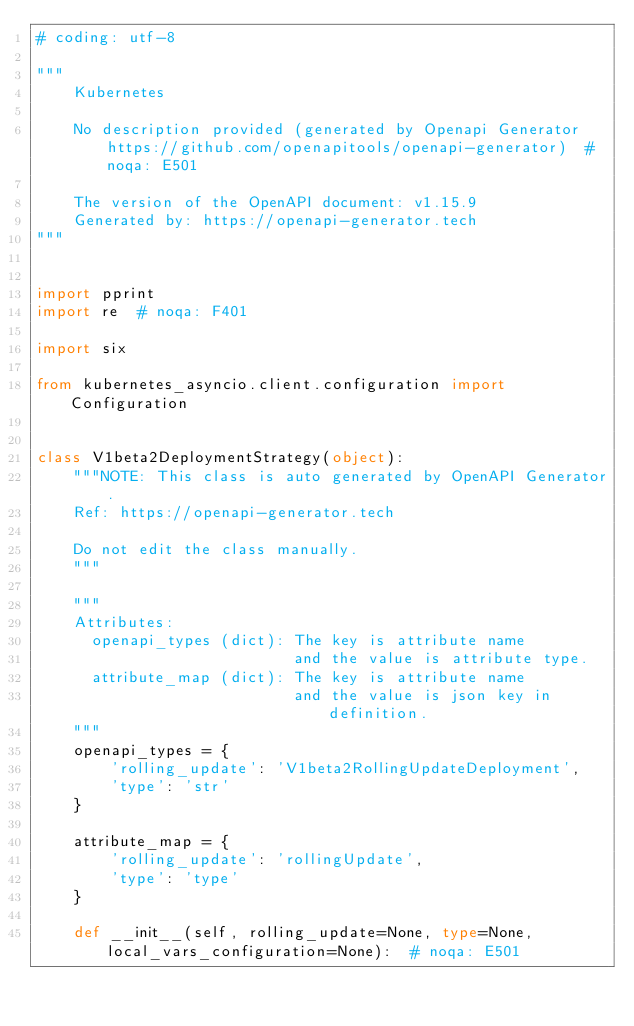<code> <loc_0><loc_0><loc_500><loc_500><_Python_># coding: utf-8

"""
    Kubernetes

    No description provided (generated by Openapi Generator https://github.com/openapitools/openapi-generator)  # noqa: E501

    The version of the OpenAPI document: v1.15.9
    Generated by: https://openapi-generator.tech
"""


import pprint
import re  # noqa: F401

import six

from kubernetes_asyncio.client.configuration import Configuration


class V1beta2DeploymentStrategy(object):
    """NOTE: This class is auto generated by OpenAPI Generator.
    Ref: https://openapi-generator.tech

    Do not edit the class manually.
    """

    """
    Attributes:
      openapi_types (dict): The key is attribute name
                            and the value is attribute type.
      attribute_map (dict): The key is attribute name
                            and the value is json key in definition.
    """
    openapi_types = {
        'rolling_update': 'V1beta2RollingUpdateDeployment',
        'type': 'str'
    }

    attribute_map = {
        'rolling_update': 'rollingUpdate',
        'type': 'type'
    }

    def __init__(self, rolling_update=None, type=None, local_vars_configuration=None):  # noqa: E501</code> 